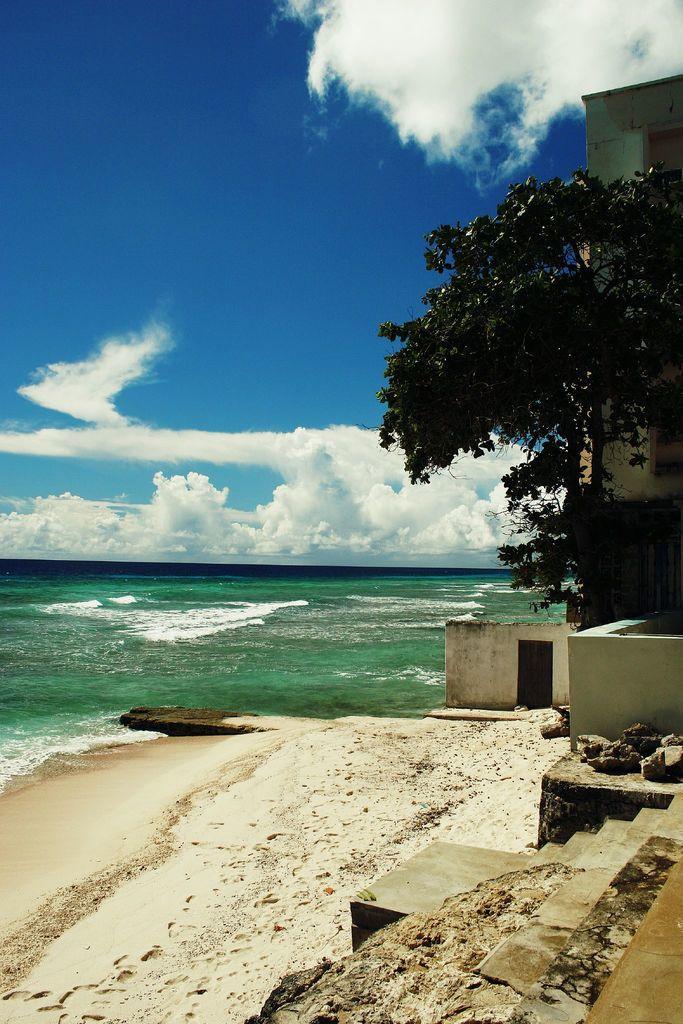In one or two sentences, can you explain what this image depicts? In this picture there is a house and a tree on the right side of the image and there are broken stairs at the bottom side of the image, there is water in the background area of the image. 